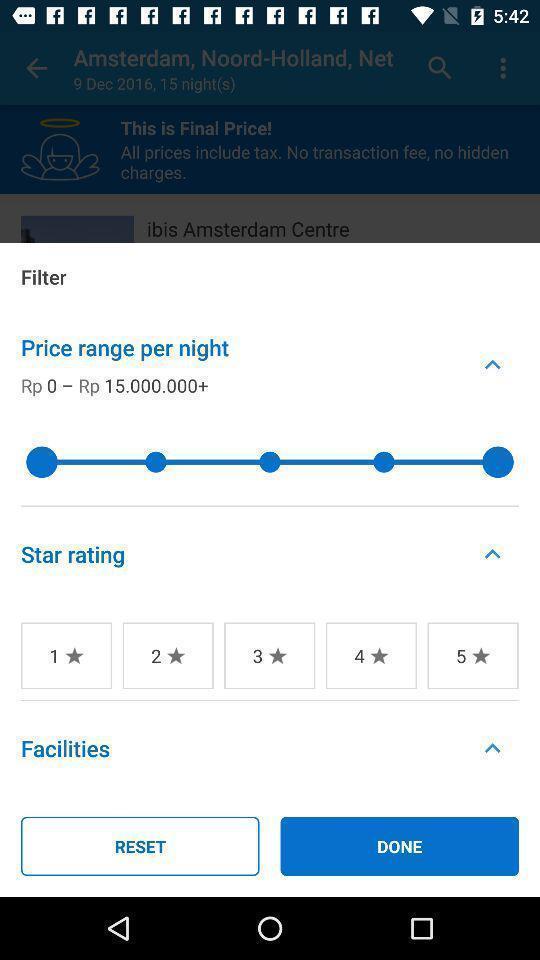Describe the visual elements of this screenshot. Screen shows filters as per a night. 